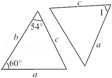Considering triangles ABC and DEF are congruent, what can be inferred about their perimeters? Given the congruence of triangles ABC and DEF, their perimeters must be equal. This implies that each side of triangle ABC is equal in length to its corresponding side in triangle DEF. Therefore, measuring one triangle's perimeter provides the perimeter of the other. 